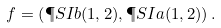Convert formula to latex. <formula><loc_0><loc_0><loc_500><loc_500>f = \left ( \P S I { b } ( 1 , 2 ) , \P S I { a } ( 1 , 2 ) \right ) .</formula> 